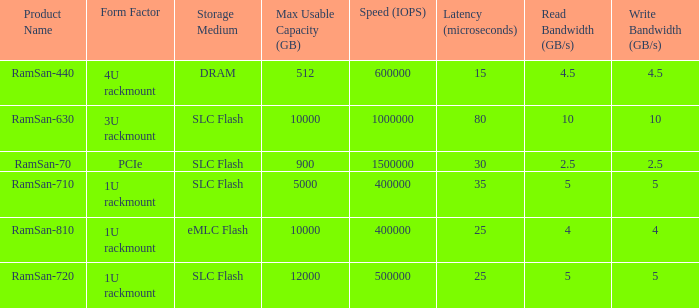List the number of ramsan-720 hard drives? 1.0. 